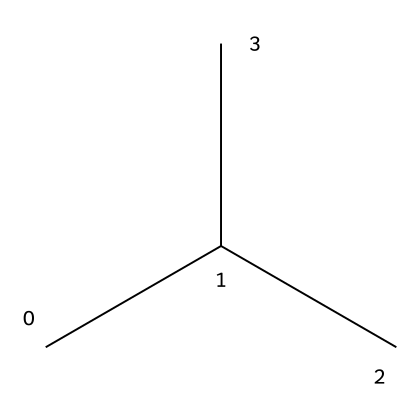What is the molecular formula of this chemical? This SMILES representation indicates a branched alkane with three carbons (C) combined with several hydrogen atoms (H). Looking at the structure, we can deduce the molecular formula as C3H8.
Answer: C3H8 How many carbon atoms are present in this chemical? By analyzing the SMILES string, which includes "CC(C)", it shows there are three carbon atoms represented in the structure.
Answer: 3 What type of polymer is represented in the chemical structure? The presence of just carbon and hydrogen in a repeating unit demonstrates that this chemical is a hydrocarbon polymer, specifically a polypropylene.
Answer: polypropylene What is the degree of saturation of this chemical? The structure consists solely of single bonds between the carbon atoms and no rings or double bonds are present. This means it is fully saturated with hydrogen atoms.
Answer: saturated How many hydrogen atoms are bonded to carbon in this structure? Each carbon in the structure bonds to hydrogen atoms to fulfill the tetravalent nature of carbon. The three carbon atoms (C3) are connected such that there are 8 hydrogen atoms around them, making it a total of 8.
Answer: 8 What type of interactions does polypropylene demonstrate when used in traditional Kurdish rugs? Polypropylene is a thermoplastic polymer, which typically shows good resistance to chemicals and moisture, thus creating durable and easy-to-clean rugs.
Answer: thermoplastic 